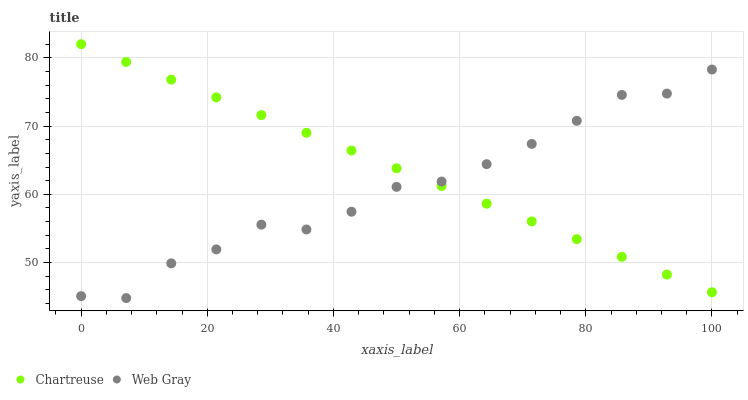Does Web Gray have the minimum area under the curve?
Answer yes or no. Yes. Does Chartreuse have the maximum area under the curve?
Answer yes or no. Yes. Does Web Gray have the maximum area under the curve?
Answer yes or no. No. Is Chartreuse the smoothest?
Answer yes or no. Yes. Is Web Gray the roughest?
Answer yes or no. Yes. Is Web Gray the smoothest?
Answer yes or no. No. Does Web Gray have the lowest value?
Answer yes or no. Yes. Does Chartreuse have the highest value?
Answer yes or no. Yes. Does Web Gray have the highest value?
Answer yes or no. No. Does Web Gray intersect Chartreuse?
Answer yes or no. Yes. Is Web Gray less than Chartreuse?
Answer yes or no. No. Is Web Gray greater than Chartreuse?
Answer yes or no. No. 